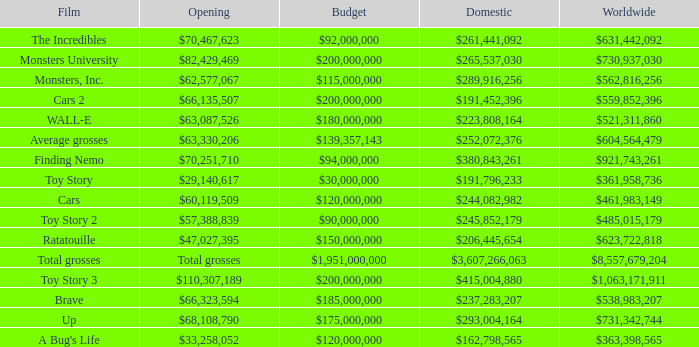WHAT IS THE OPENING WITH A WORLDWIDE NUMBER OF $559,852,396? $66,135,507. 